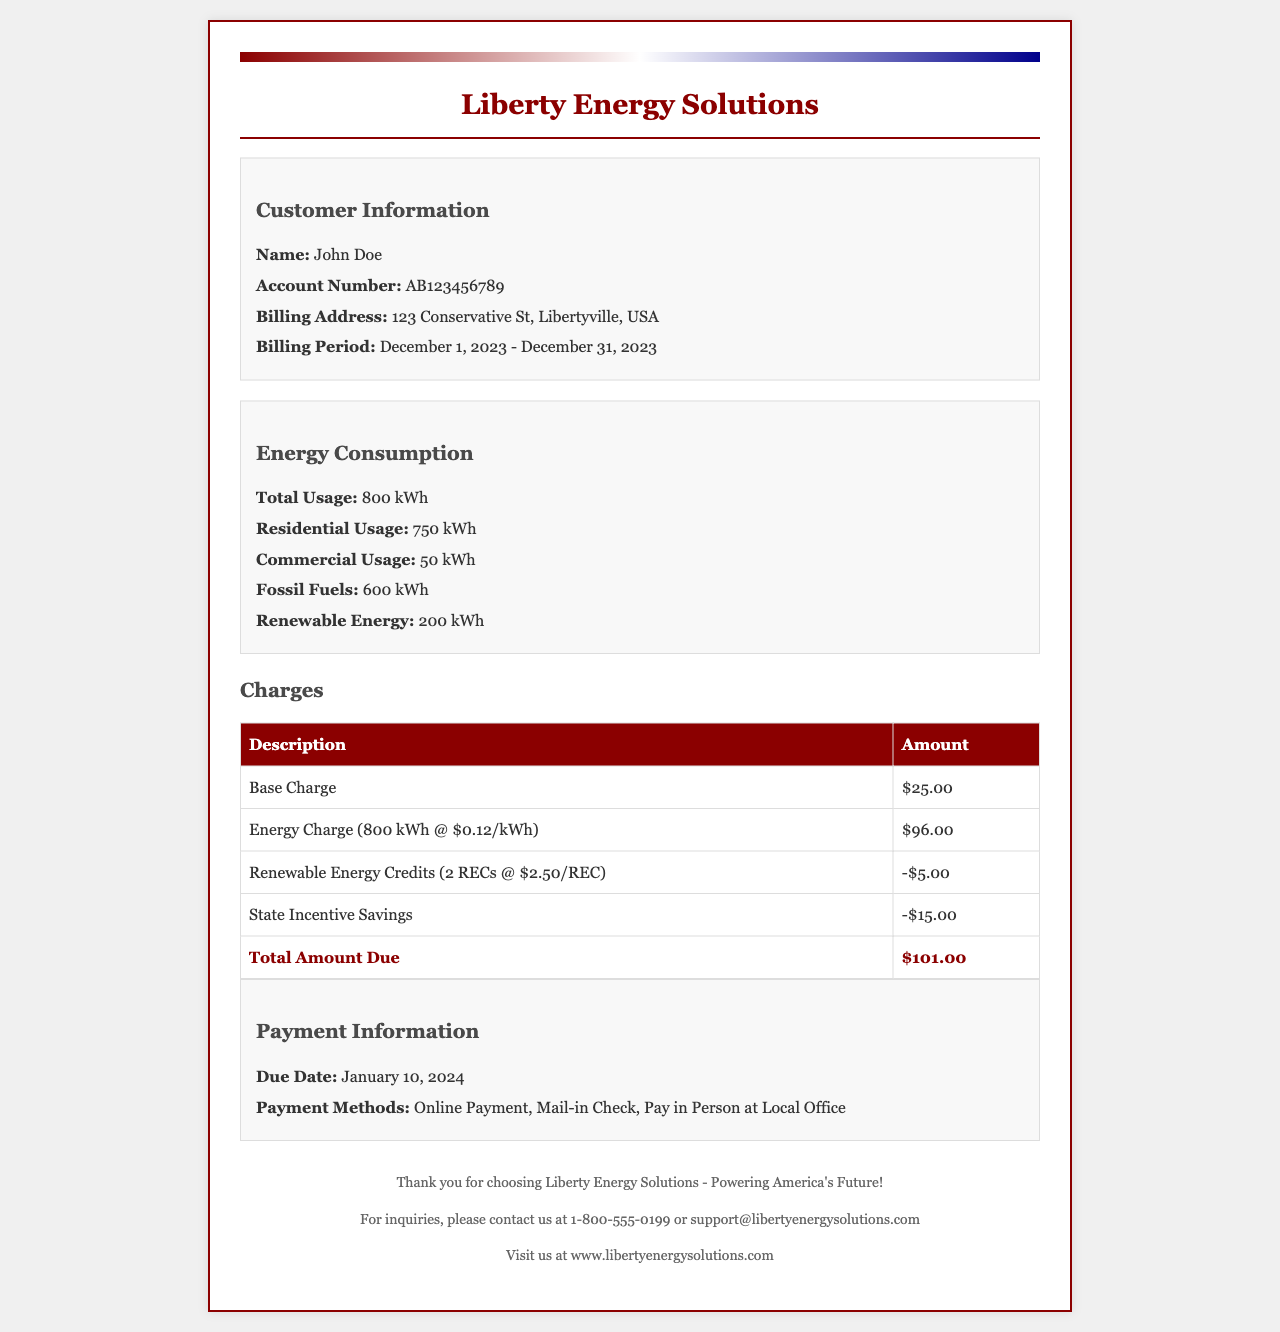What is the customer's name? The customer's name is listed in the customer information section of the document.
Answer: John Doe What is the total energy usage for December 2023? The total energy usage is specified under the energy consumption section.
Answer: 800 kWh How much is the base charge? The base charge is detailed in the charges table.
Answer: $25.00 What are the Renewable Energy Credits charged? The Renewable Energy Credits amount is noted in the charges table as a credit.
Answer: -$5.00 What is the due date for the payment? The due date is stated in the payment information section.
Answer: January 10, 2024 What is the total amount due? The total amount due is clearly indicated at the bottom of the charges table.
Answer: $101.00 How many kWh of renewable energy were used? The amount of renewable energy used is indicated in the energy consumption section.
Answer: 200 kWh What percentage of total usage is from fossil fuels? This requires calculating: (600 kWh fossil fuels / 800 kWh total usage) * 100.
Answer: 75% What is the billing period for this receipt? The billing period is provided in the customer information section.
Answer: December 1, 2023 - December 31, 2023 